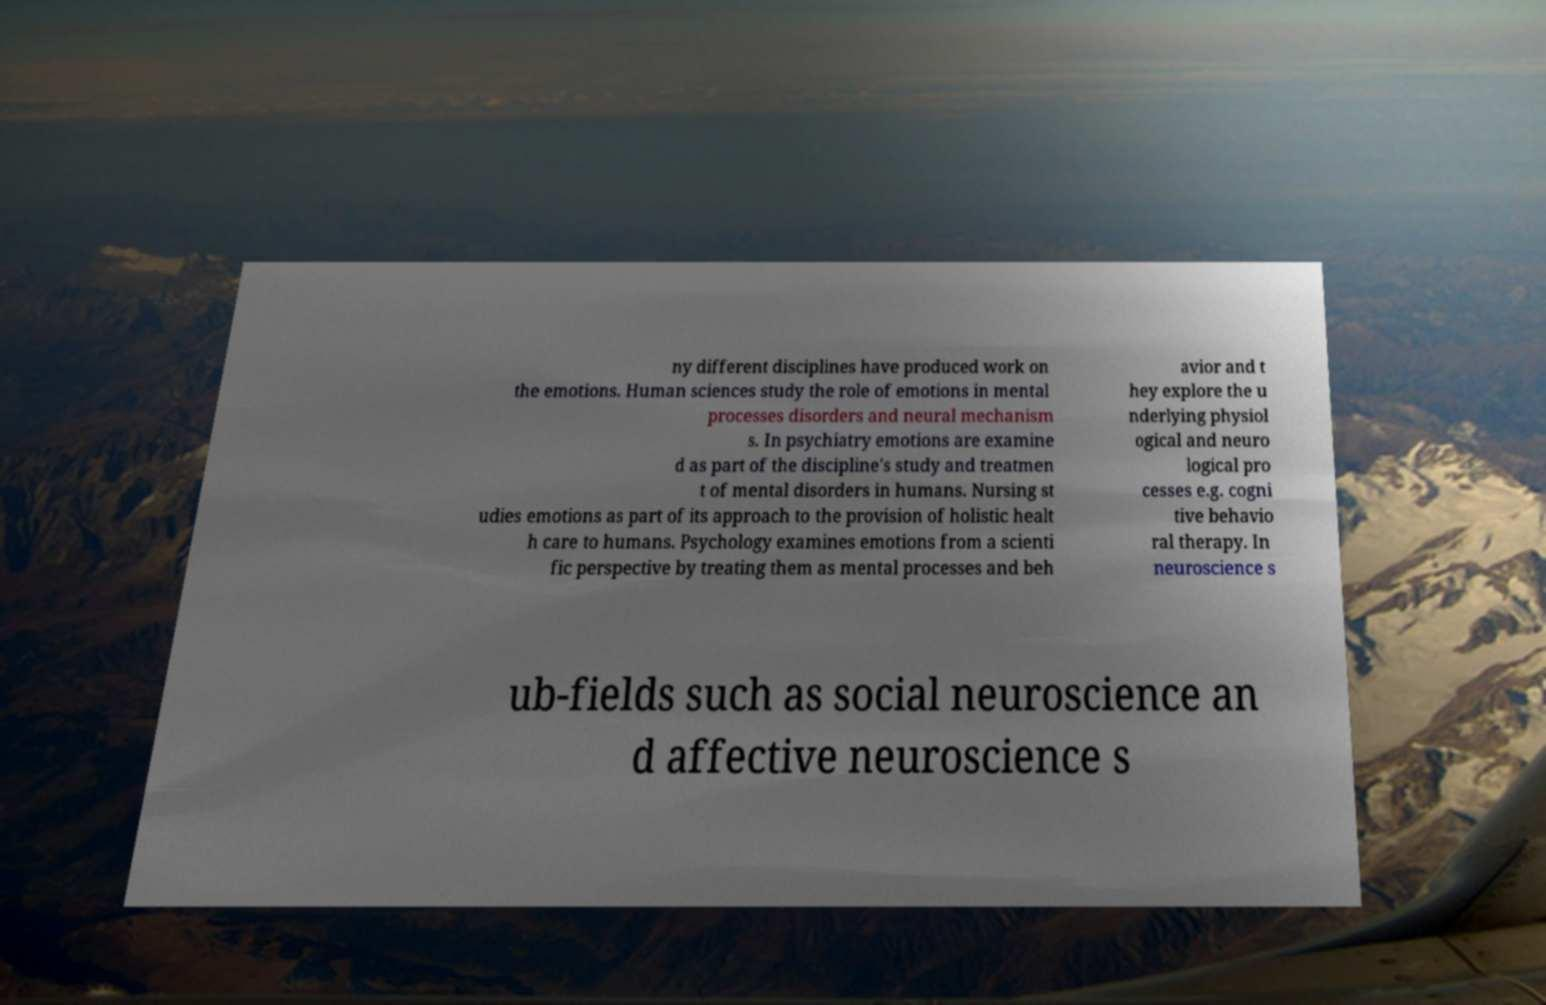Please read and relay the text visible in this image. What does it say? ny different disciplines have produced work on the emotions. Human sciences study the role of emotions in mental processes disorders and neural mechanism s. In psychiatry emotions are examine d as part of the discipline's study and treatmen t of mental disorders in humans. Nursing st udies emotions as part of its approach to the provision of holistic healt h care to humans. Psychology examines emotions from a scienti fic perspective by treating them as mental processes and beh avior and t hey explore the u nderlying physiol ogical and neuro logical pro cesses e.g. cogni tive behavio ral therapy. In neuroscience s ub-fields such as social neuroscience an d affective neuroscience s 